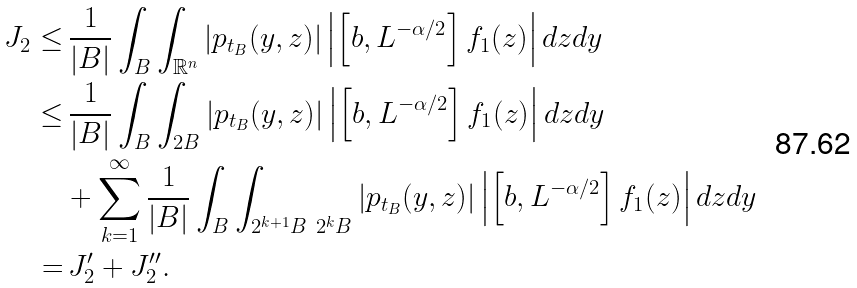Convert formula to latex. <formula><loc_0><loc_0><loc_500><loc_500>J _ { 2 } \leq & \, \frac { 1 } { | B | } \int _ { B } \int _ { \mathbb { R } ^ { n } } \left | p _ { t _ { B } } ( y , z ) \right | \left | \left [ b , L ^ { - \alpha / 2 } \right ] f _ { 1 } ( z ) \right | d z d y \\ \leq & \, \frac { 1 } { | B | } \int _ { B } \int _ { 2 B } \left | p _ { t _ { B } } ( y , z ) \right | \left | \left [ b , L ^ { - \alpha / 2 } \right ] f _ { 1 } ( z ) \right | d z d y \\ & + \sum _ { k = 1 } ^ { \infty } \frac { 1 } { | B | } \int _ { B } \int _ { 2 ^ { k + 1 } B \ 2 ^ { k } B } \left | p _ { t _ { B } } ( y , z ) \right | \left | \left [ b , L ^ { - \alpha / 2 } \right ] f _ { 1 } ( z ) \right | d z d y \\ = & \, J ^ { \prime } _ { 2 } + J ^ { \prime \prime } _ { 2 } .</formula> 